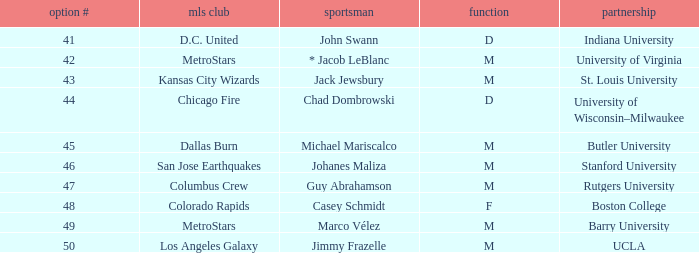What is the position of the Colorado Rapids team? F. 